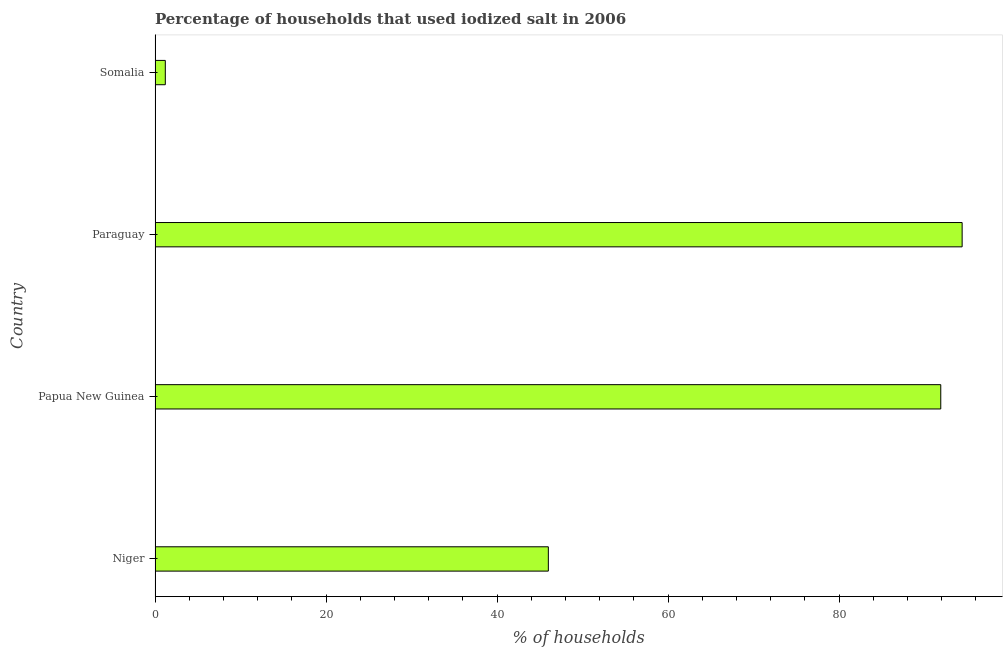Does the graph contain any zero values?
Keep it short and to the point. No. Does the graph contain grids?
Provide a succinct answer. No. What is the title of the graph?
Make the answer very short. Percentage of households that used iodized salt in 2006. What is the label or title of the X-axis?
Your answer should be compact. % of households. What is the label or title of the Y-axis?
Your answer should be compact. Country. What is the percentage of households where iodized salt is consumed in Paraguay?
Ensure brevity in your answer.  94.4. Across all countries, what is the maximum percentage of households where iodized salt is consumed?
Your response must be concise. 94.4. Across all countries, what is the minimum percentage of households where iodized salt is consumed?
Your answer should be very brief. 1.2. In which country was the percentage of households where iodized salt is consumed maximum?
Provide a short and direct response. Paraguay. In which country was the percentage of households where iodized salt is consumed minimum?
Your answer should be compact. Somalia. What is the sum of the percentage of households where iodized salt is consumed?
Provide a succinct answer. 233.5. What is the difference between the percentage of households where iodized salt is consumed in Papua New Guinea and Somalia?
Keep it short and to the point. 90.7. What is the average percentage of households where iodized salt is consumed per country?
Provide a succinct answer. 58.38. What is the median percentage of households where iodized salt is consumed?
Your answer should be compact. 68.95. In how many countries, is the percentage of households where iodized salt is consumed greater than 12 %?
Make the answer very short. 3. What is the ratio of the percentage of households where iodized salt is consumed in Papua New Guinea to that in Somalia?
Make the answer very short. 76.58. Is the percentage of households where iodized salt is consumed in Papua New Guinea less than that in Paraguay?
Provide a short and direct response. Yes. What is the difference between the highest and the second highest percentage of households where iodized salt is consumed?
Give a very brief answer. 2.5. Is the sum of the percentage of households where iodized salt is consumed in Niger and Paraguay greater than the maximum percentage of households where iodized salt is consumed across all countries?
Make the answer very short. Yes. What is the difference between the highest and the lowest percentage of households where iodized salt is consumed?
Your answer should be very brief. 93.2. Are all the bars in the graph horizontal?
Keep it short and to the point. Yes. What is the difference between two consecutive major ticks on the X-axis?
Keep it short and to the point. 20. Are the values on the major ticks of X-axis written in scientific E-notation?
Your answer should be very brief. No. What is the % of households of Niger?
Give a very brief answer. 46. What is the % of households of Papua New Guinea?
Provide a succinct answer. 91.9. What is the % of households of Paraguay?
Ensure brevity in your answer.  94.4. What is the difference between the % of households in Niger and Papua New Guinea?
Offer a terse response. -45.9. What is the difference between the % of households in Niger and Paraguay?
Provide a short and direct response. -48.4. What is the difference between the % of households in Niger and Somalia?
Give a very brief answer. 44.8. What is the difference between the % of households in Papua New Guinea and Somalia?
Make the answer very short. 90.7. What is the difference between the % of households in Paraguay and Somalia?
Keep it short and to the point. 93.2. What is the ratio of the % of households in Niger to that in Papua New Guinea?
Keep it short and to the point. 0.5. What is the ratio of the % of households in Niger to that in Paraguay?
Your answer should be compact. 0.49. What is the ratio of the % of households in Niger to that in Somalia?
Offer a terse response. 38.33. What is the ratio of the % of households in Papua New Guinea to that in Somalia?
Make the answer very short. 76.58. What is the ratio of the % of households in Paraguay to that in Somalia?
Your answer should be compact. 78.67. 